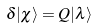<formula> <loc_0><loc_0><loc_500><loc_500>\delta | \chi \rangle = Q | \lambda \rangle</formula> 